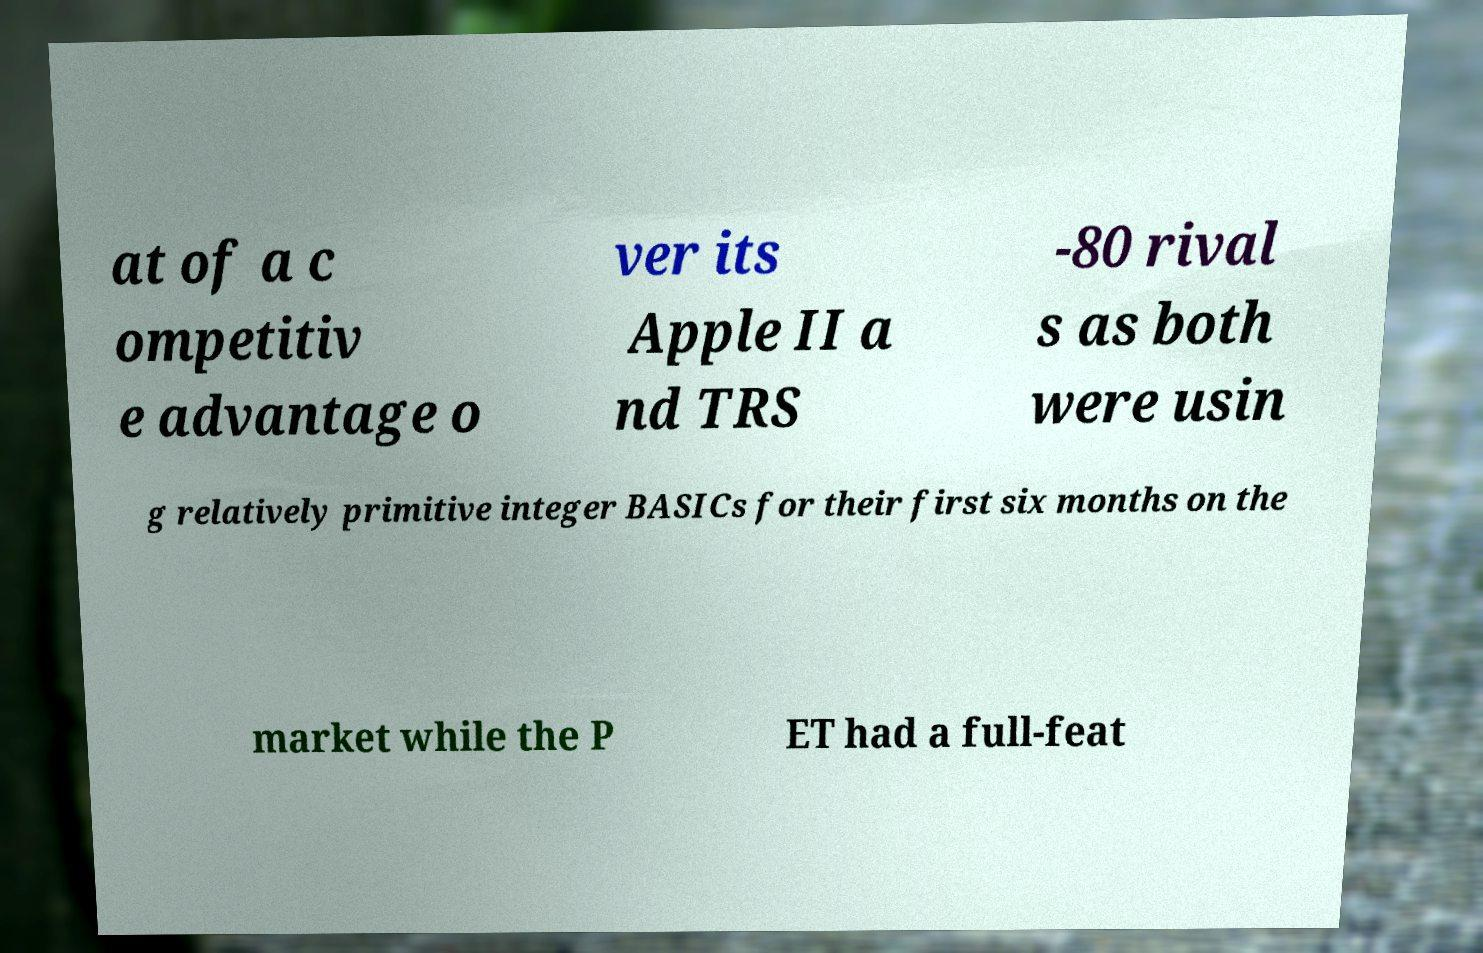Please read and relay the text visible in this image. What does it say? at of a c ompetitiv e advantage o ver its Apple II a nd TRS -80 rival s as both were usin g relatively primitive integer BASICs for their first six months on the market while the P ET had a full-feat 